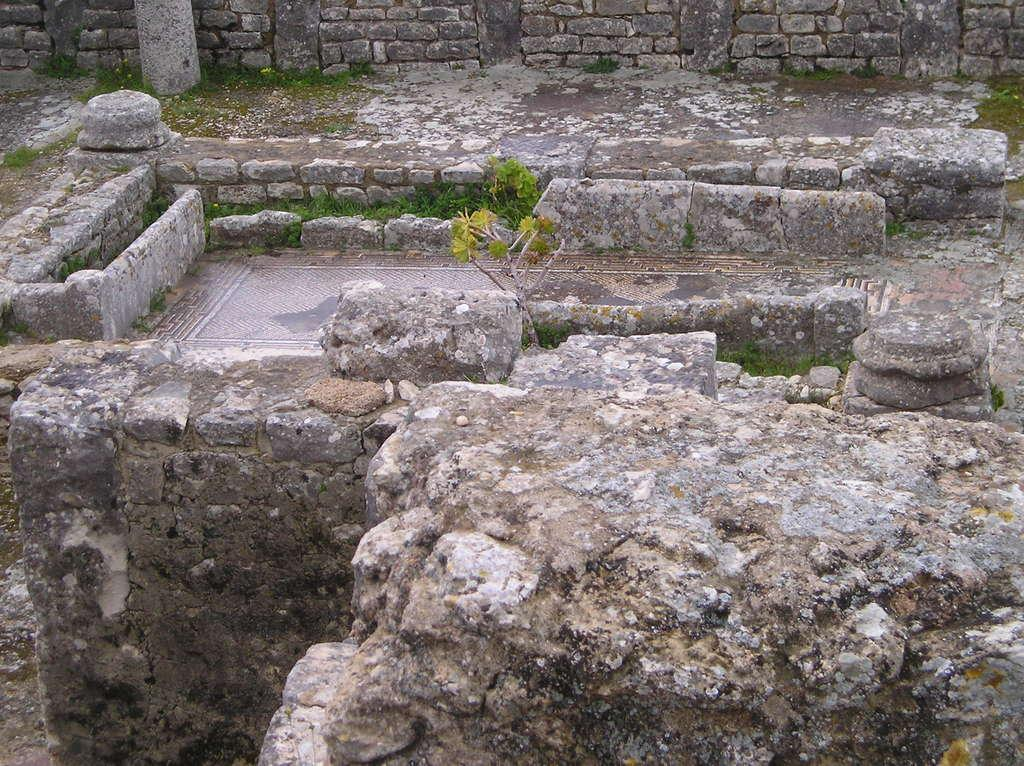What is the main feature in the middle of the image? There is a floor in the middle of the image. What type of material is used for the walls surrounding the floor? The walls surrounding the floor are made of stone. Are there any walls at the top of the image? Yes, there is a stone wall at the top of the image. How many spiders can be seen crawling on the stone walls in the image? There are no spiders visible in the image; it only features a floor and stone walls. Is there any poison present in the image? There is no mention of poison in the image, as it only contains a floor and stone walls. 